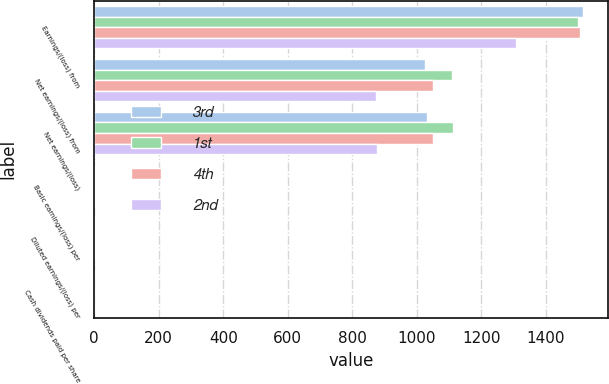Convert chart. <chart><loc_0><loc_0><loc_500><loc_500><stacked_bar_chart><ecel><fcel>Earnings/(loss) from<fcel>Net earnings/(loss) from<fcel>Net earnings/(loss)<fcel>Basic earnings/(loss) per<fcel>Diluted earnings/(loss) per<fcel>Cash dividends paid per share<nl><fcel>3rd<fcel>1516<fcel>1027<fcel>1033<fcel>1.39<fcel>1.36<fcel>0.35<nl><fcel>1st<fcel>1499<fcel>1109<fcel>1114<fcel>1.47<fcel>1.44<fcel>0.35<nl><fcel>4th<fcel>1506<fcel>1049<fcel>1050<fcel>1.38<fcel>1.35<fcel>0.35<nl><fcel>2nd<fcel>1309<fcel>873<fcel>877<fcel>1.15<fcel>1.13<fcel>0.35<nl></chart> 